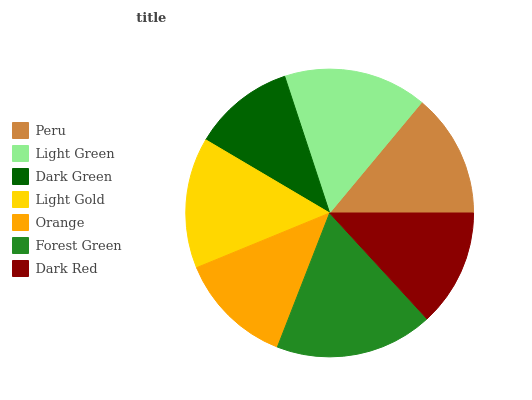Is Dark Green the minimum?
Answer yes or no. Yes. Is Forest Green the maximum?
Answer yes or no. Yes. Is Light Green the minimum?
Answer yes or no. No. Is Light Green the maximum?
Answer yes or no. No. Is Light Green greater than Peru?
Answer yes or no. Yes. Is Peru less than Light Green?
Answer yes or no. Yes. Is Peru greater than Light Green?
Answer yes or no. No. Is Light Green less than Peru?
Answer yes or no. No. Is Peru the high median?
Answer yes or no. Yes. Is Peru the low median?
Answer yes or no. Yes. Is Orange the high median?
Answer yes or no. No. Is Forest Green the low median?
Answer yes or no. No. 